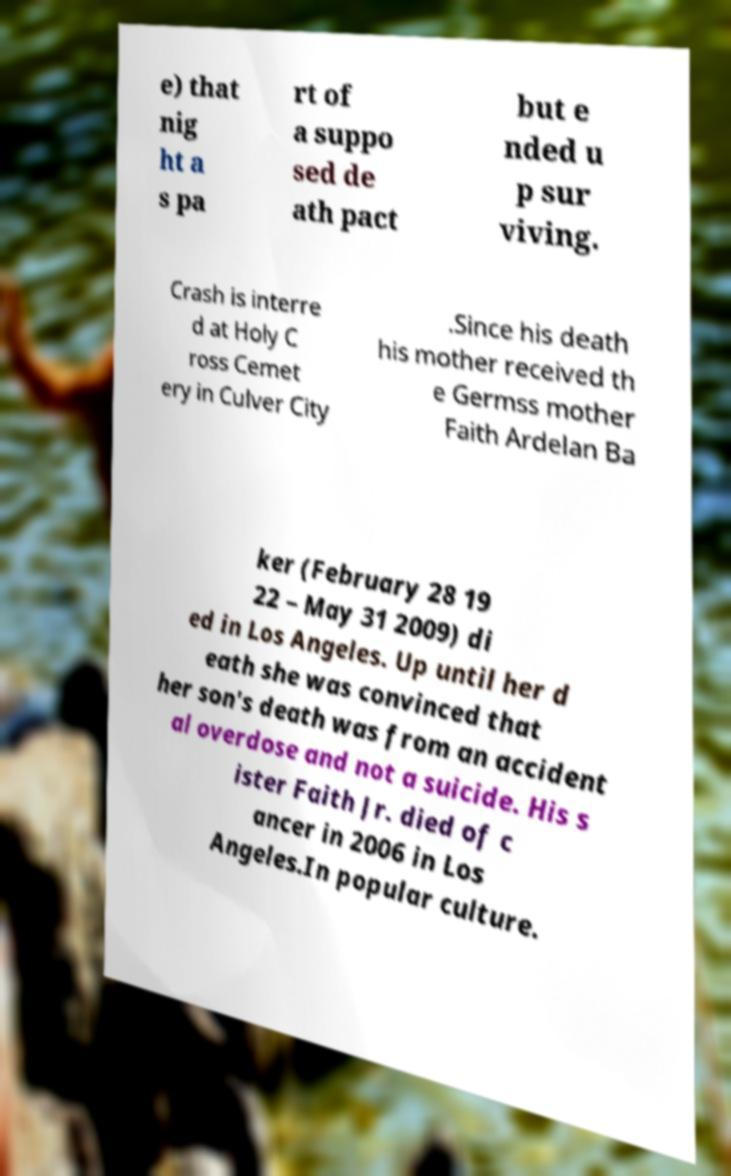Could you assist in decoding the text presented in this image and type it out clearly? e) that nig ht a s pa rt of a suppo sed de ath pact but e nded u p sur viving. Crash is interre d at Holy C ross Cemet ery in Culver City .Since his death his mother received th e Germss mother Faith Ardelan Ba ker (February 28 19 22 – May 31 2009) di ed in Los Angeles. Up until her d eath she was convinced that her son's death was from an accident al overdose and not a suicide. His s ister Faith Jr. died of c ancer in 2006 in Los Angeles.In popular culture. 